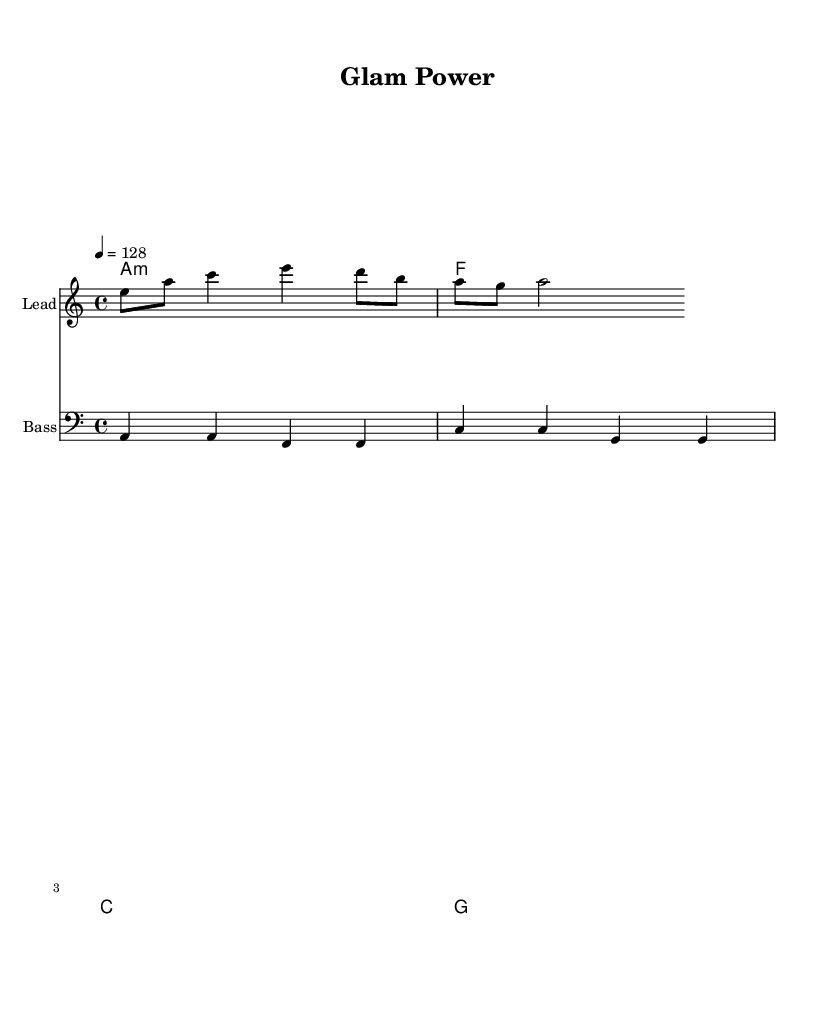What is the key signature of this music? The key signature indicated at the beginning of the sheet music is A minor, which has no sharps or flats.
Answer: A minor What is the time signature of this music? The time signature shown in the sheet music is 4/4, which means there are four beats in each measure and a quarter note gets one beat.
Answer: 4/4 What is the tempo marking for this piece? The tempo marking specified in the score is 128 beats per minute, indicated with the note "4 = 128".
Answer: 128 What is the first note of the melody? The first note of the melody, as indicated in the sheet music, is E in the octave relative to middle C, which is depicted as an eighth note.
Answer: E How many measures are there in the harmonies section? The harmonies section consists of four measures, with each measure representing a chord played for the entire duration of the measure.
Answer: 4 Which instrument plays the bass line? The bass line is notated on a staff labeled "Bass," indicating that this part is intended for a bass instrument.
Answer: Bass What is the last chord in the harmonies? The last chord in the harmonies is G major, which is shown as the final chord in the chord progression listed.
Answer: G 